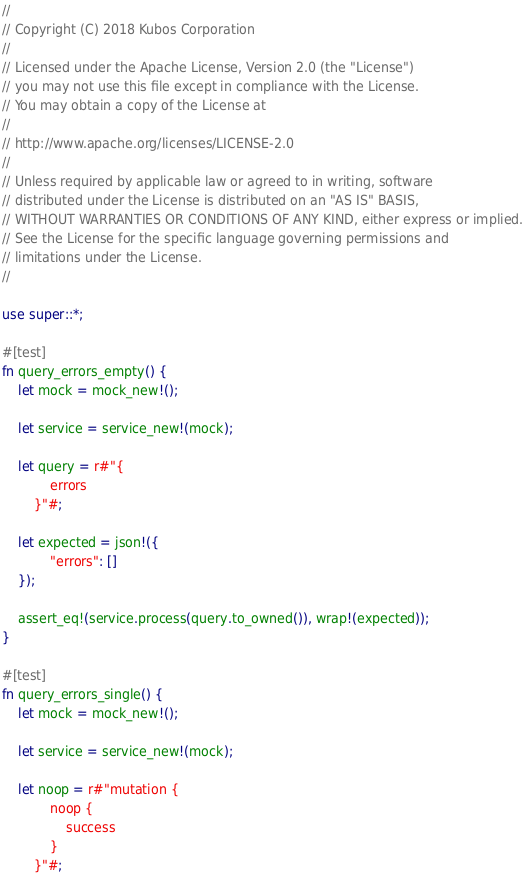<code> <loc_0><loc_0><loc_500><loc_500><_Rust_>//
// Copyright (C) 2018 Kubos Corporation
//
// Licensed under the Apache License, Version 2.0 (the "License")
// you may not use this file except in compliance with the License.
// You may obtain a copy of the License at
//
// http://www.apache.org/licenses/LICENSE-2.0
//
// Unless required by applicable law or agreed to in writing, software
// distributed under the License is distributed on an "AS IS" BASIS,
// WITHOUT WARRANTIES OR CONDITIONS OF ANY KIND, either express or implied.
// See the License for the specific language governing permissions and
// limitations under the License.
//

use super::*;

#[test]
fn query_errors_empty() {
    let mock = mock_new!();

    let service = service_new!(mock);

    let query = r#"{
            errors
        }"#;

    let expected = json!({
            "errors": []
    });

    assert_eq!(service.process(query.to_owned()), wrap!(expected));
}

#[test]
fn query_errors_single() {
    let mock = mock_new!();

    let service = service_new!(mock);

    let noop = r#"mutation {
            noop {
                success
            }
        }"#;
</code> 